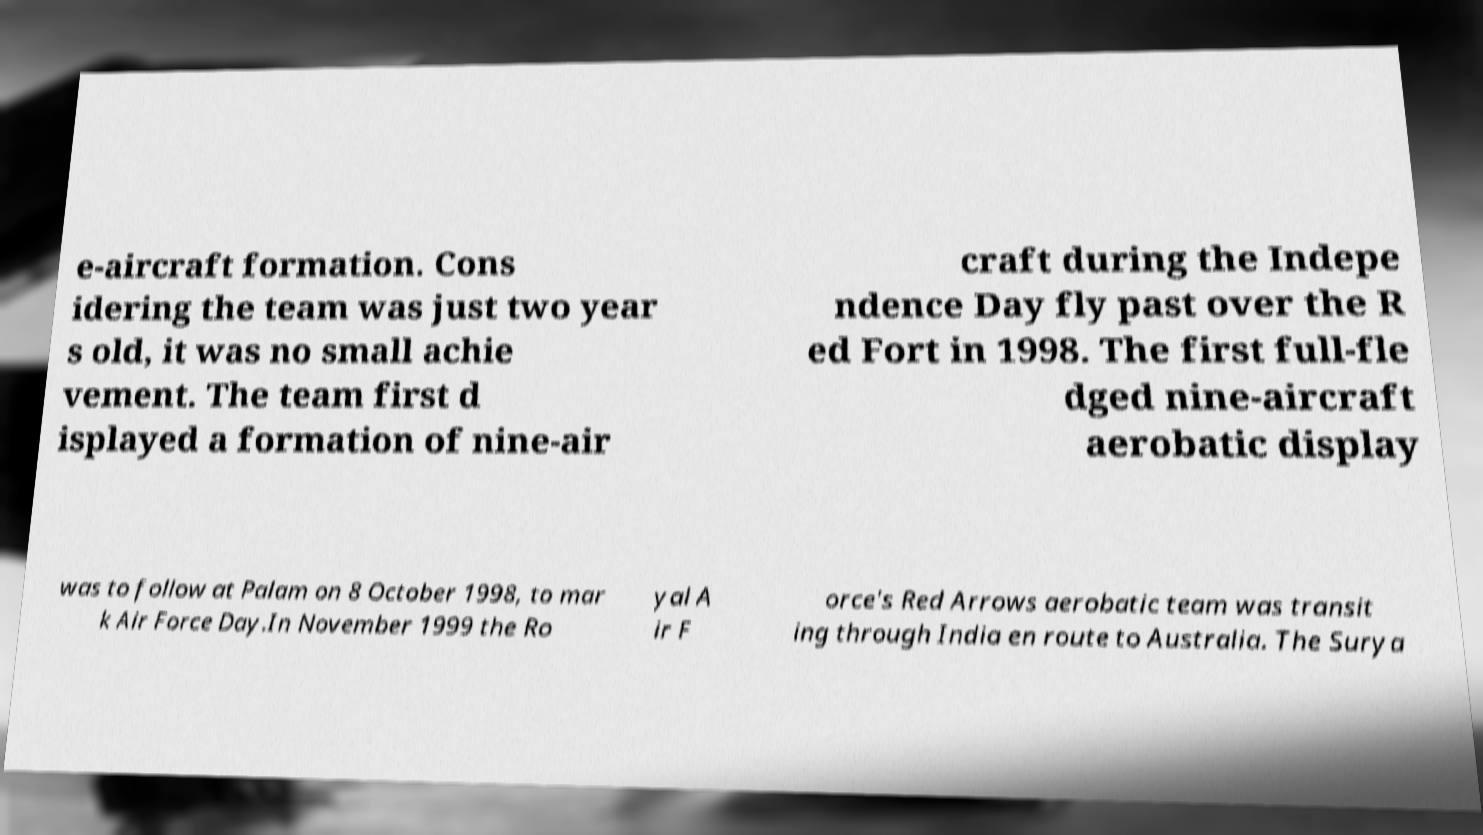Can you accurately transcribe the text from the provided image for me? e-aircraft formation. Cons idering the team was just two year s old, it was no small achie vement. The team first d isplayed a formation of nine-air craft during the Indepe ndence Day fly past over the R ed Fort in 1998. The first full-fle dged nine-aircraft aerobatic display was to follow at Palam on 8 October 1998, to mar k Air Force Day.In November 1999 the Ro yal A ir F orce's Red Arrows aerobatic team was transit ing through India en route to Australia. The Surya 